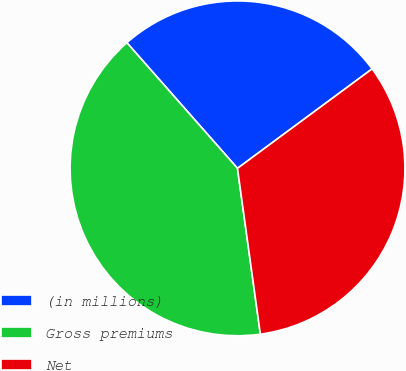Convert chart to OTSL. <chart><loc_0><loc_0><loc_500><loc_500><pie_chart><fcel>(in millions)<fcel>Gross premiums<fcel>Net<nl><fcel>26.36%<fcel>40.69%<fcel>32.94%<nl></chart> 